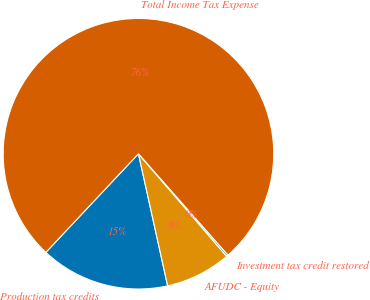Convert chart. <chart><loc_0><loc_0><loc_500><loc_500><pie_chart><fcel>Production tax credits<fcel>AFUDC - Equity<fcel>Investment tax credit restored<fcel>Total Income Tax Expense<nl><fcel>15.46%<fcel>7.84%<fcel>0.21%<fcel>76.49%<nl></chart> 